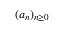<formula> <loc_0><loc_0><loc_500><loc_500>( a _ { n } ) _ { n \geq 0 }</formula> 